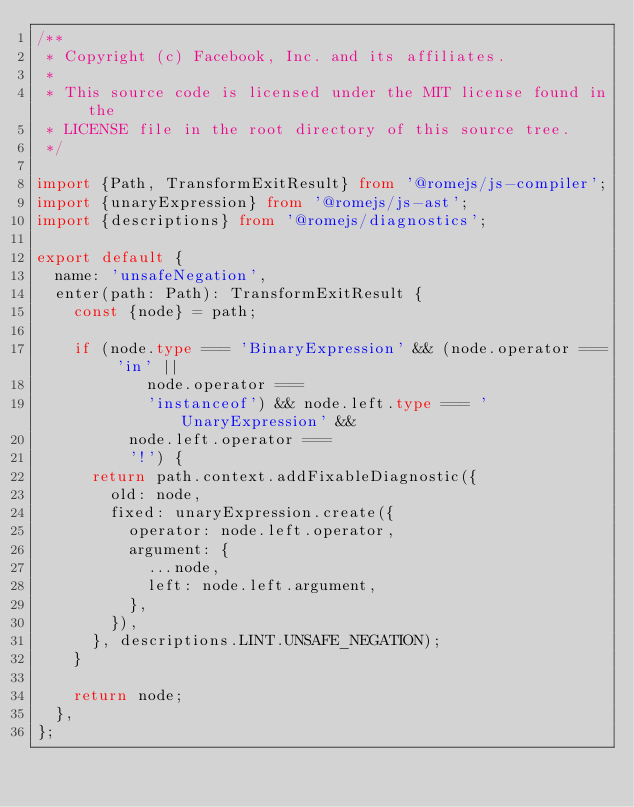<code> <loc_0><loc_0><loc_500><loc_500><_TypeScript_>/**
 * Copyright (c) Facebook, Inc. and its affiliates.
 *
 * This source code is licensed under the MIT license found in the
 * LICENSE file in the root directory of this source tree.
 */

import {Path, TransformExitResult} from '@romejs/js-compiler';
import {unaryExpression} from '@romejs/js-ast';
import {descriptions} from '@romejs/diagnostics';

export default {
  name: 'unsafeNegation',
  enter(path: Path): TransformExitResult {
    const {node} = path;

    if (node.type === 'BinaryExpression' && (node.operator === 'in' ||
            node.operator ===
            'instanceof') && node.left.type === 'UnaryExpression' &&
          node.left.operator ===
          '!') {
      return path.context.addFixableDiagnostic({
        old: node,
        fixed: unaryExpression.create({
          operator: node.left.operator,
          argument: {
            ...node,
            left: node.left.argument,
          },
        }),
      }, descriptions.LINT.UNSAFE_NEGATION);
    }

    return node;
  },
};
</code> 